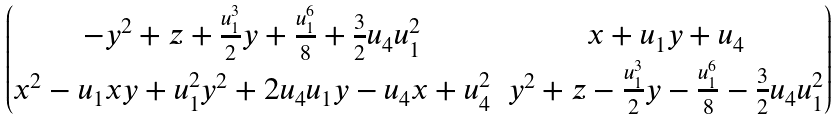<formula> <loc_0><loc_0><loc_500><loc_500>\begin{pmatrix} - y ^ { 2 } + z + \frac { u _ { 1 } ^ { 3 } } { 2 } y + \frac { u _ { 1 } ^ { 6 } } { 8 } + \frac { 3 } { 2 } u _ { 4 } u _ { 1 } ^ { 2 } & x + u _ { 1 } y + u _ { 4 } \\ x ^ { 2 } - u _ { 1 } x y + u _ { 1 } ^ { 2 } y ^ { 2 } + 2 u _ { 4 } u _ { 1 } y - u _ { 4 } x + u _ { 4 } ^ { 2 } & y ^ { 2 } + z - \frac { u _ { 1 } ^ { 3 } } { 2 } y - \frac { u _ { 1 } ^ { 6 } } { 8 } - \frac { 3 } { 2 } u _ { 4 } u _ { 1 } ^ { 2 } \end{pmatrix}</formula> 